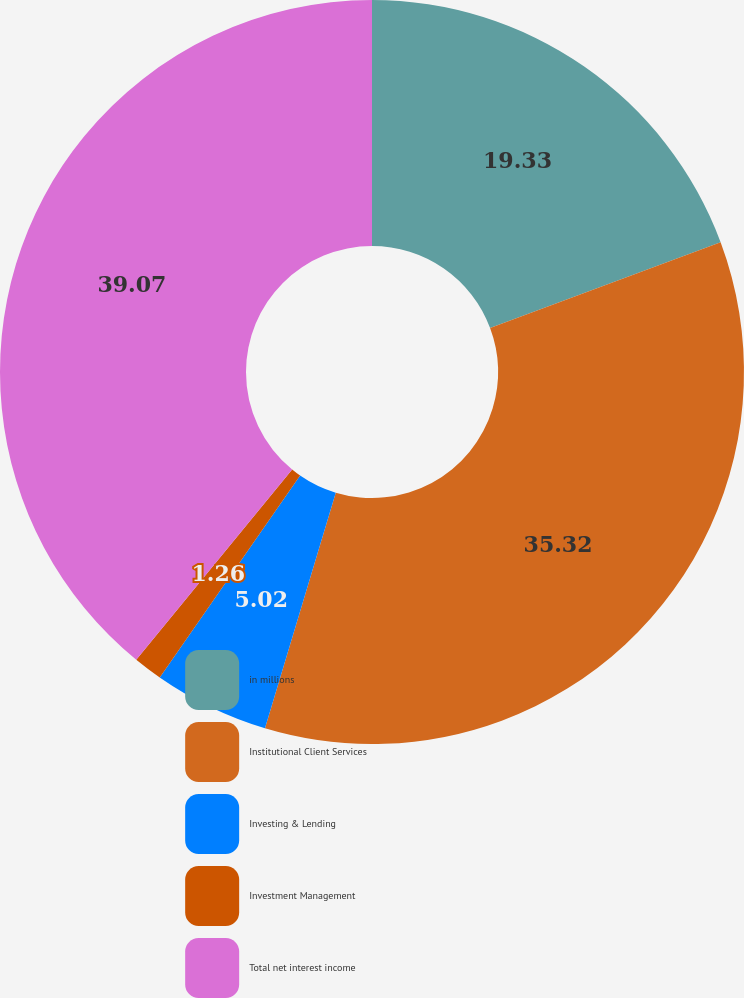<chart> <loc_0><loc_0><loc_500><loc_500><pie_chart><fcel>in millions<fcel>Institutional Client Services<fcel>Investing & Lending<fcel>Investment Management<fcel>Total net interest income<nl><fcel>19.33%<fcel>35.32%<fcel>5.02%<fcel>1.26%<fcel>39.08%<nl></chart> 